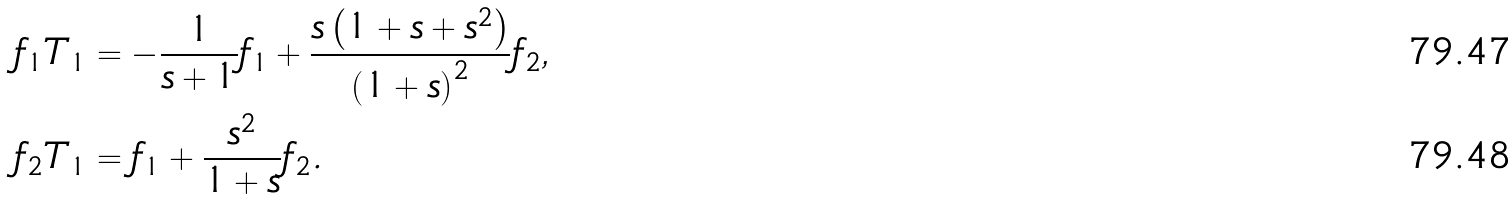Convert formula to latex. <formula><loc_0><loc_0><loc_500><loc_500>f _ { 1 } T _ { 1 } & = - \frac { 1 } { s + 1 } f _ { 1 } + \frac { s \left ( 1 + s + s ^ { 2 } \right ) } { \left ( 1 + s \right ) ^ { 2 } } f _ { 2 } , \\ f _ { 2 } T _ { 1 } & = f _ { 1 } + \frac { s ^ { 2 } } { 1 + s } f _ { 2 } .</formula> 